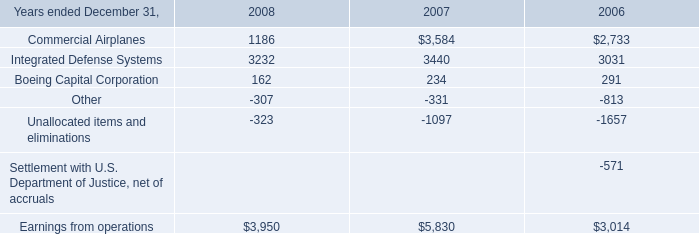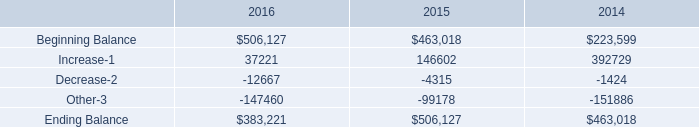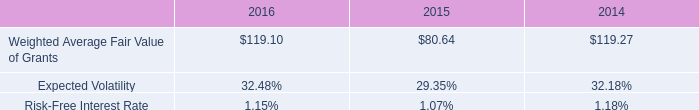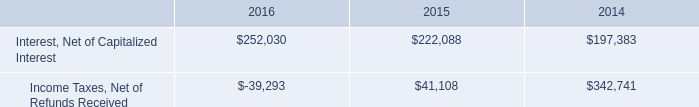What's the average of Ending Balance of 2014, and Interest, Net of Capitalized Interest of 2014 ? 
Computations: ((463018.0 + 197383.0) / 2)
Answer: 330200.5. 